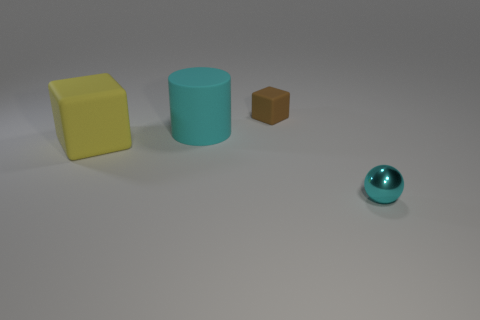Is the big yellow rubber object the same shape as the tiny matte thing?
Make the answer very short. Yes. How many yellow cubes have the same size as the brown matte block?
Ensure brevity in your answer.  0. How many tiny objects are cyan cylinders or yellow matte objects?
Your answer should be compact. 0. Is there a small red metallic cylinder?
Provide a succinct answer. No. Are there more small brown cubes that are in front of the large yellow rubber cube than large cyan cylinders right of the metal thing?
Keep it short and to the point. No. There is a matte thing behind the cyan thing that is behind the tiny cyan object; what color is it?
Offer a very short reply. Brown. Are there any things of the same color as the ball?
Your answer should be compact. Yes. How big is the thing that is on the right side of the small thing that is behind the small object that is in front of the cyan cylinder?
Provide a succinct answer. Small. The big cyan matte thing is what shape?
Provide a short and direct response. Cylinder. The cylinder that is the same color as the tiny shiny sphere is what size?
Provide a short and direct response. Large. 